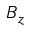<formula> <loc_0><loc_0><loc_500><loc_500>B _ { z }</formula> 